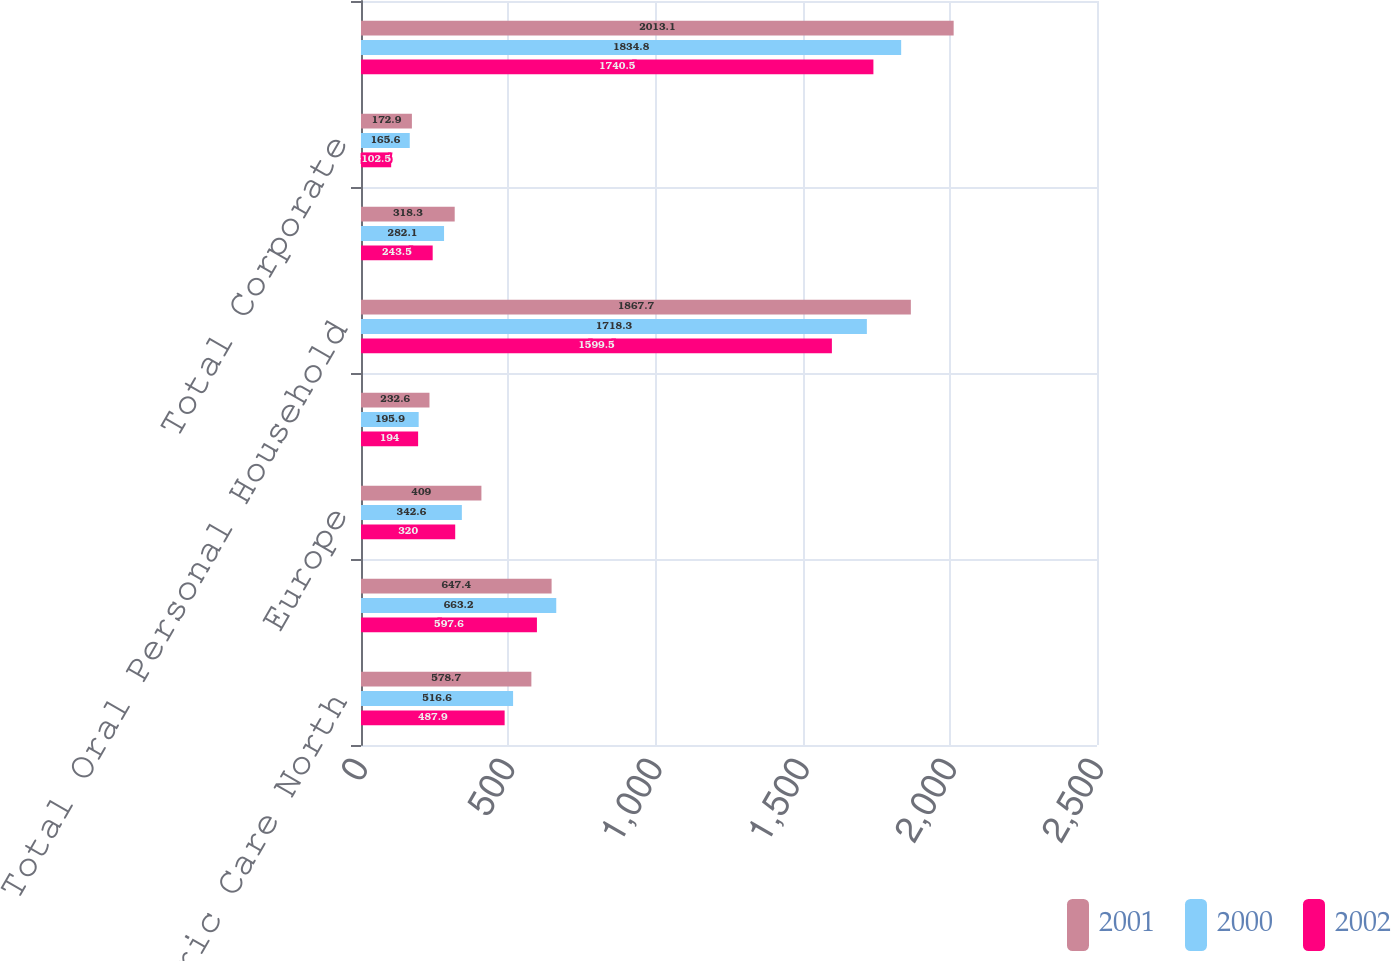<chart> <loc_0><loc_0><loc_500><loc_500><stacked_bar_chart><ecel><fcel>Surface and Fabric Care North<fcel>Latin America<fcel>Europe<fcel>Asia/Africa<fcel>Total Oral Personal Household<fcel>Total Pet Nutrition<fcel>Total Corporate<fcel>Total Operating Profit<nl><fcel>2001<fcel>578.7<fcel>647.4<fcel>409<fcel>232.6<fcel>1867.7<fcel>318.3<fcel>172.9<fcel>2013.1<nl><fcel>2000<fcel>516.6<fcel>663.2<fcel>342.6<fcel>195.9<fcel>1718.3<fcel>282.1<fcel>165.6<fcel>1834.8<nl><fcel>2002<fcel>487.9<fcel>597.6<fcel>320<fcel>194<fcel>1599.5<fcel>243.5<fcel>102.5<fcel>1740.5<nl></chart> 